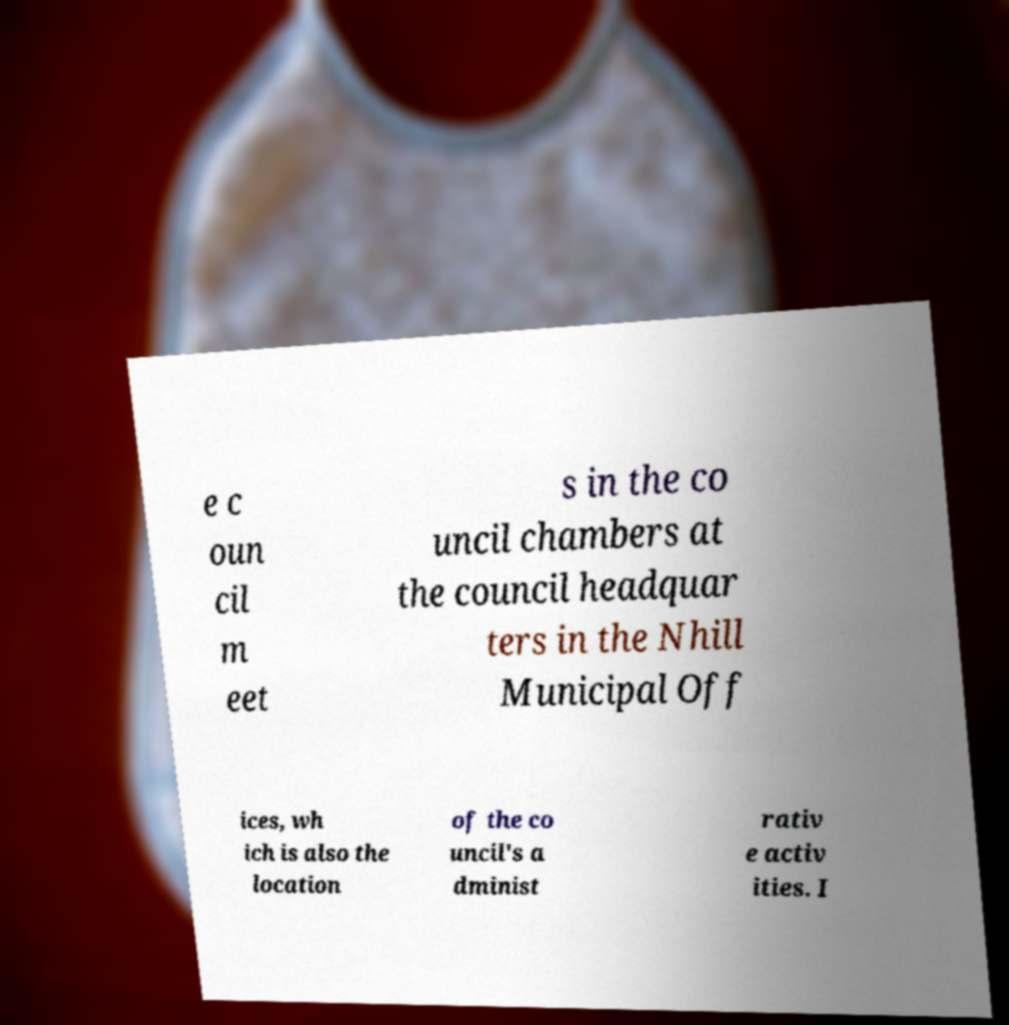Could you extract and type out the text from this image? e c oun cil m eet s in the co uncil chambers at the council headquar ters in the Nhill Municipal Off ices, wh ich is also the location of the co uncil's a dminist rativ e activ ities. I 